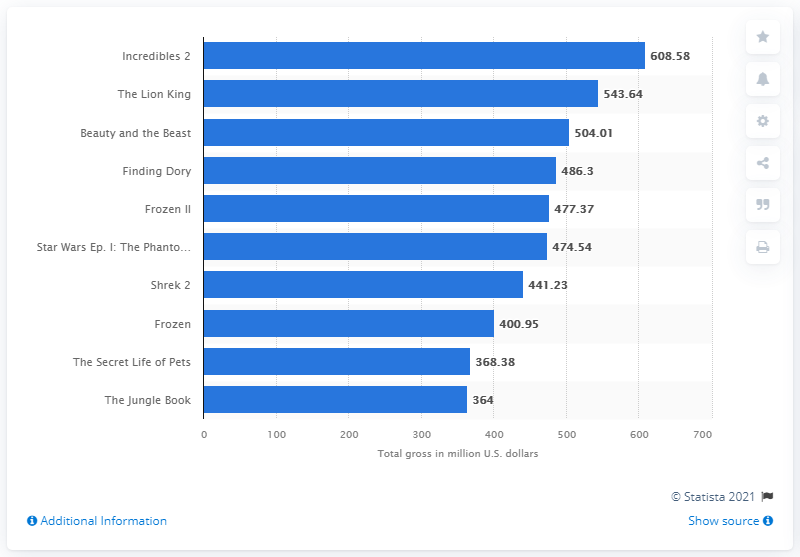Highlight a few significant elements in this photo. The total gross revenue of Incredibles 2 in the United States from 1995 to 2021 was approximately $608.58 million. 